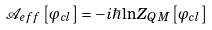Convert formula to latex. <formula><loc_0><loc_0><loc_500><loc_500>\mathcal { A } _ { e f f } \left [ \varphi _ { c l } \right ] = - i \hbar { \ln } Z _ { Q M } \left [ \varphi _ { c l } \right ]</formula> 